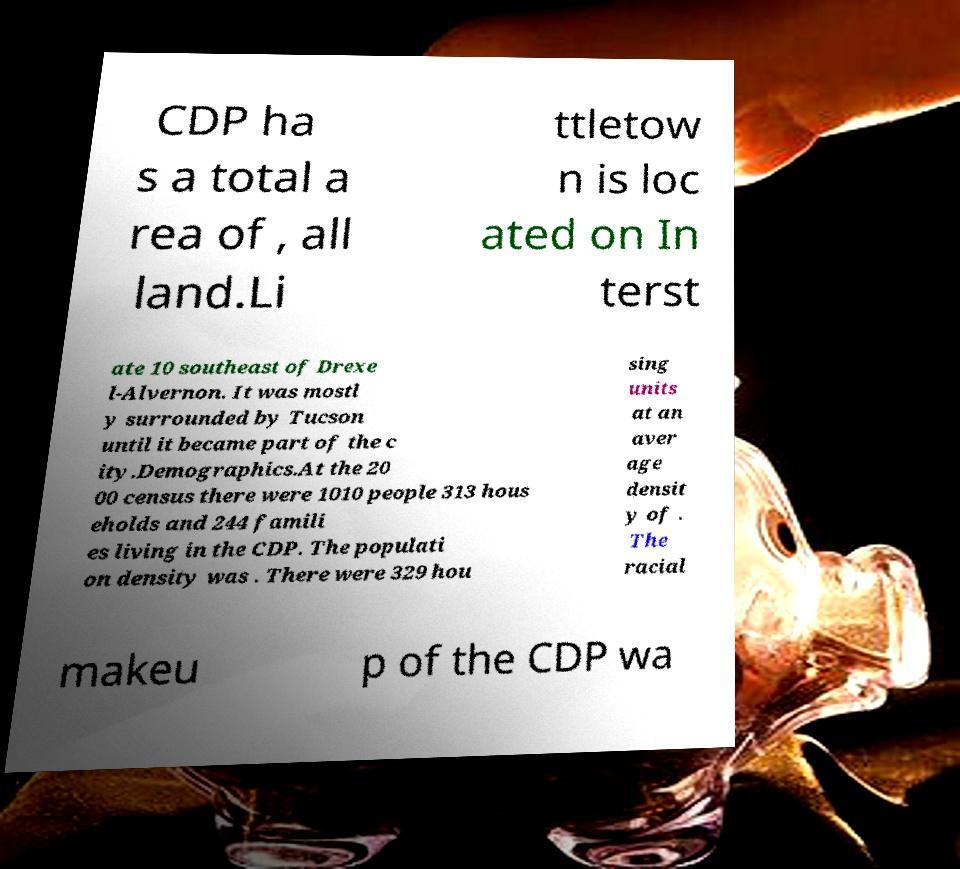Can you accurately transcribe the text from the provided image for me? CDP ha s a total a rea of , all land.Li ttletow n is loc ated on In terst ate 10 southeast of Drexe l-Alvernon. It was mostl y surrounded by Tucson until it became part of the c ity.Demographics.At the 20 00 census there were 1010 people 313 hous eholds and 244 famili es living in the CDP. The populati on density was . There were 329 hou sing units at an aver age densit y of . The racial makeu p of the CDP wa 